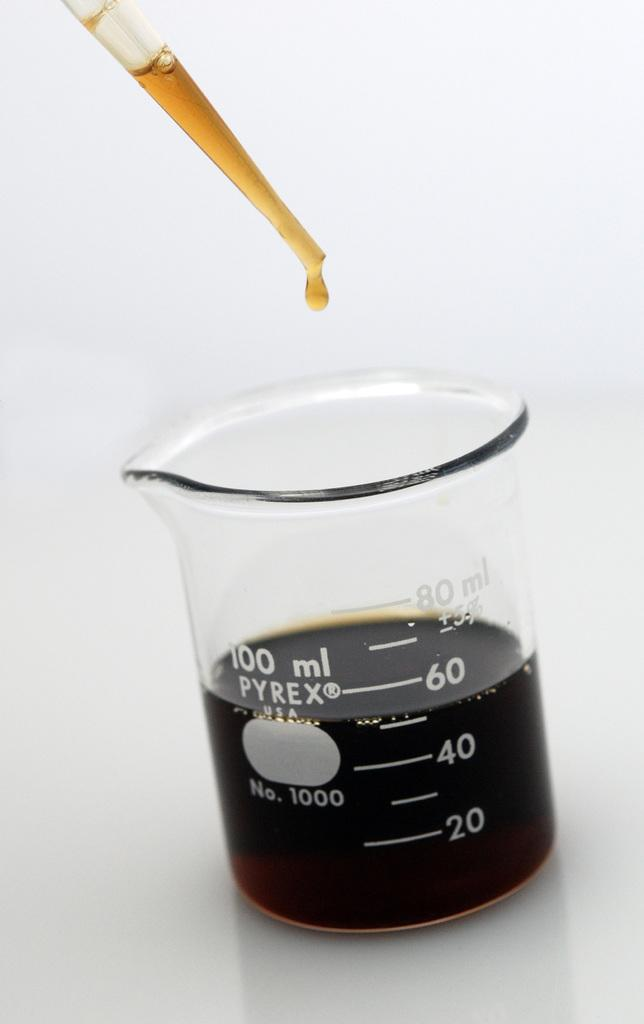Provide a one-sentence caption for the provided image. A small Pyrex beaker that currently holds 50 ml of liquid. 